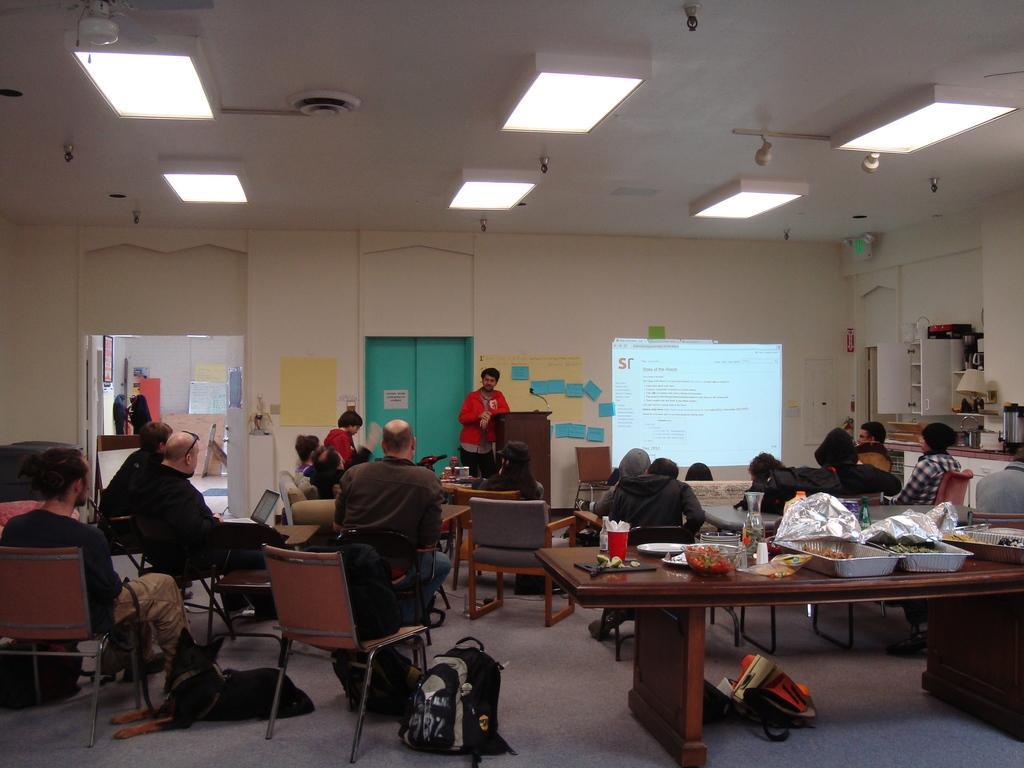How would you summarize this image in a sentence or two? In the middle there is a man he wear red jacket. In the middle there is a podium ,chair,screen and door. On the right there is a table on that there is a tray ,bowl ,cup and some food items. On the left there is a man he is sitting on the chair ,he wear black t shirt and trouser. At the top there are many lights. 